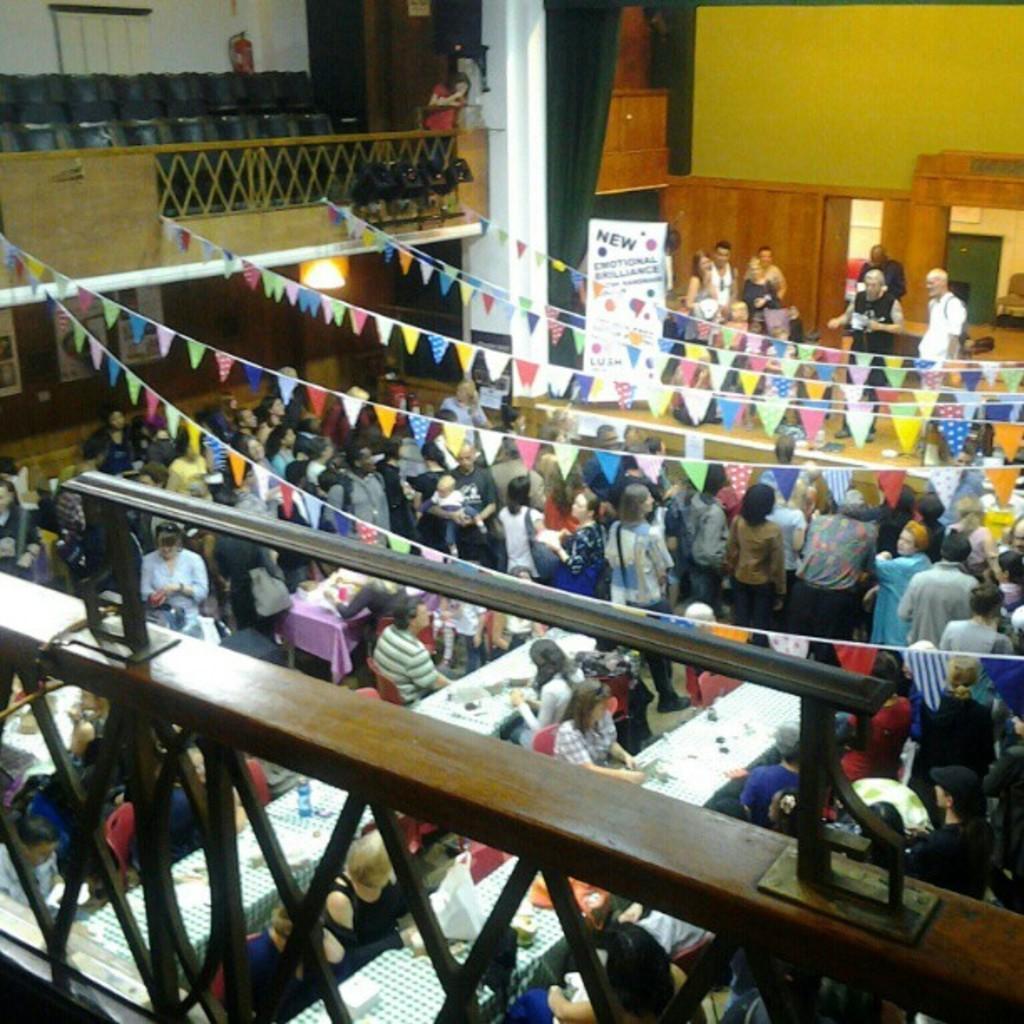How would you summarize this image in a sentence or two? This picture is clicked inside. In the foreground we can see the wooden objects and in the center we can see the group of people and we can see the flags are hanging on the ropes and there is a banner on which we can see the text is printed. In the background we can see the speakers, deck rail, pillar, wall and some other objects. 